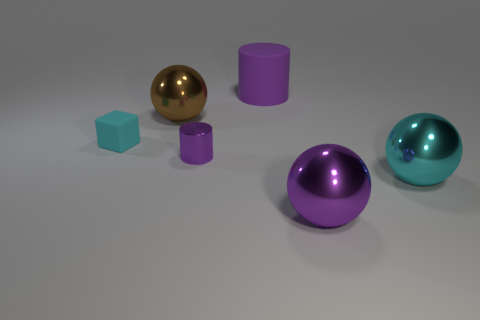What material is the cylinder behind the block?
Give a very brief answer. Rubber. What is the size of the purple ball that is the same material as the large brown ball?
Your response must be concise. Large. How many big yellow rubber things are the same shape as the big cyan thing?
Provide a succinct answer. 0. There is a brown object; does it have the same shape as the matte thing that is right of the large brown object?
Give a very brief answer. No. What is the shape of the big metal object that is the same color as the cube?
Ensure brevity in your answer.  Sphere. Are there any large green cubes that have the same material as the purple ball?
Provide a short and direct response. No. Are there any other things that are made of the same material as the tiny cylinder?
Provide a succinct answer. Yes. The cyan object that is to the right of the sphere that is behind the small purple metallic cylinder is made of what material?
Ensure brevity in your answer.  Metal. What size is the ball that is right of the large purple thing that is in front of the large shiny object that is left of the purple metallic cylinder?
Keep it short and to the point. Large. What number of other objects are the same shape as the large brown object?
Provide a succinct answer. 2. 